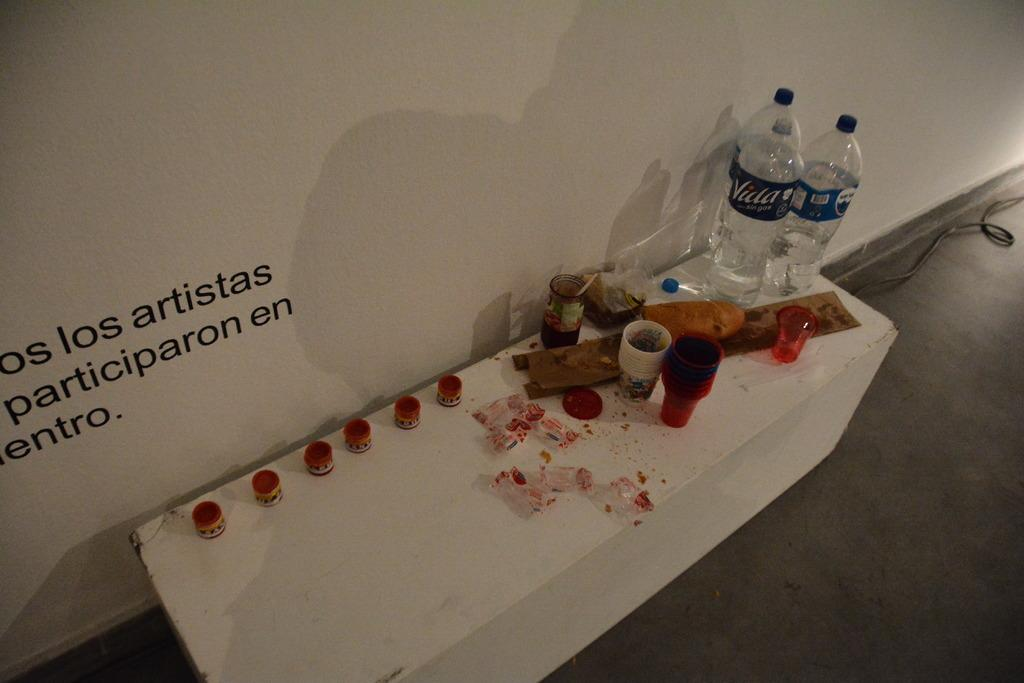<image>
Render a clear and concise summary of the photo. Several paints and bottles of water with the logo for Vida are arranged on a white table. 